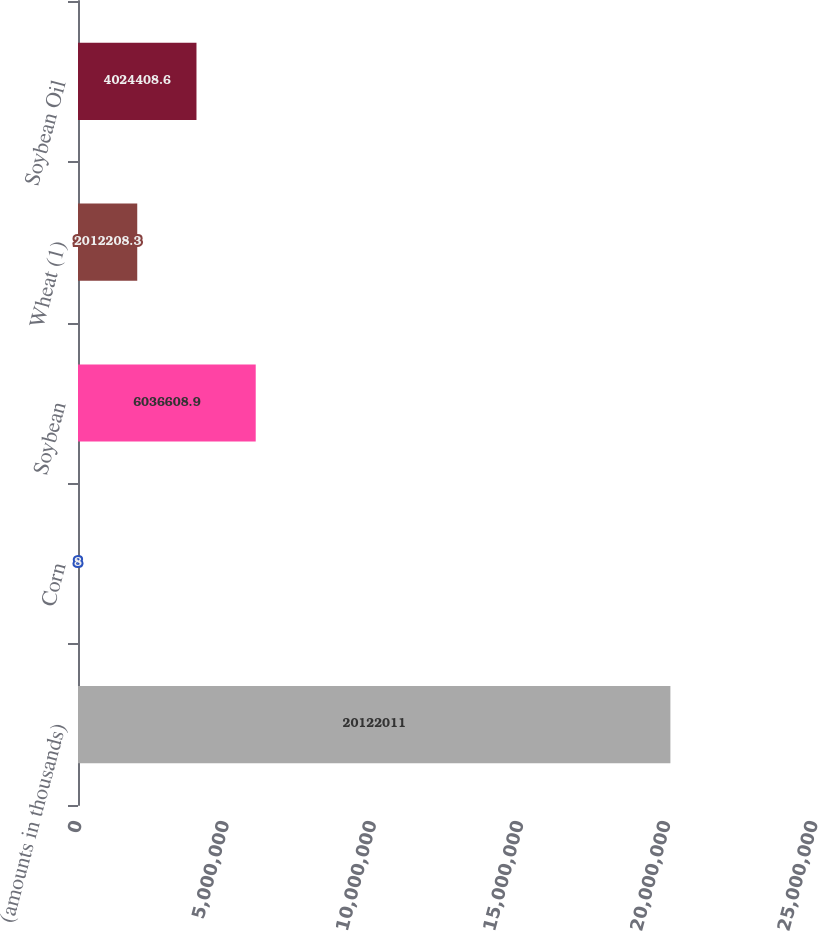<chart> <loc_0><loc_0><loc_500><loc_500><bar_chart><fcel>(amounts in thousands)<fcel>Corn<fcel>Soybean<fcel>Wheat (1)<fcel>Soybean Oil<nl><fcel>2.0122e+07<fcel>8<fcel>6.03661e+06<fcel>2.01221e+06<fcel>4.02441e+06<nl></chart> 